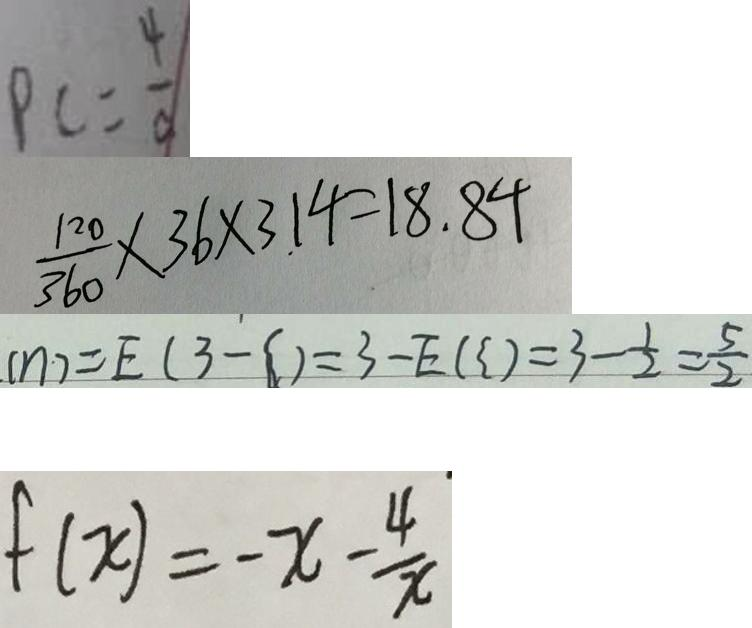<formula> <loc_0><loc_0><loc_500><loc_500>P C = \frac { 4 } { c } 
 \frac { 1 2 0 } { 3 6 0 } \times 3 6 \times 3 . 1 4 = 1 8 . 8 4 
 ( \eta ) = E ( 3 - \zeta ) = 3 - E ( = 3 - \zeta ) = 3 - \frac { 1 } { 2 } = \frac { 5 } { 2 } 
 f ( x ) = - x - \frac { 4 } { x }</formula> 